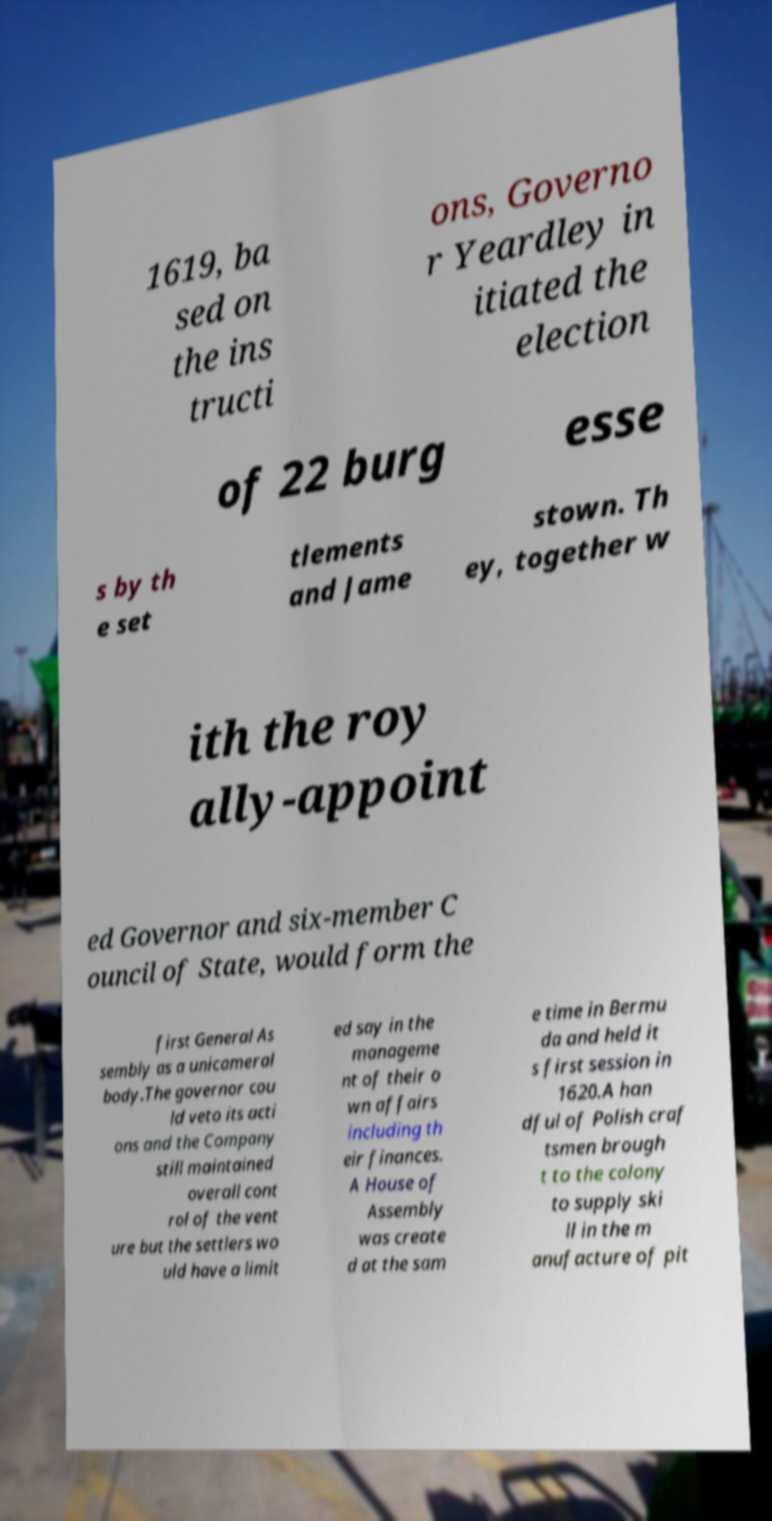There's text embedded in this image that I need extracted. Can you transcribe it verbatim? 1619, ba sed on the ins tructi ons, Governo r Yeardley in itiated the election of 22 burg esse s by th e set tlements and Jame stown. Th ey, together w ith the roy ally-appoint ed Governor and six-member C ouncil of State, would form the first General As sembly as a unicameral body.The governor cou ld veto its acti ons and the Company still maintained overall cont rol of the vent ure but the settlers wo uld have a limit ed say in the manageme nt of their o wn affairs including th eir finances. A House of Assembly was create d at the sam e time in Bermu da and held it s first session in 1620.A han dful of Polish craf tsmen brough t to the colony to supply ski ll in the m anufacture of pit 